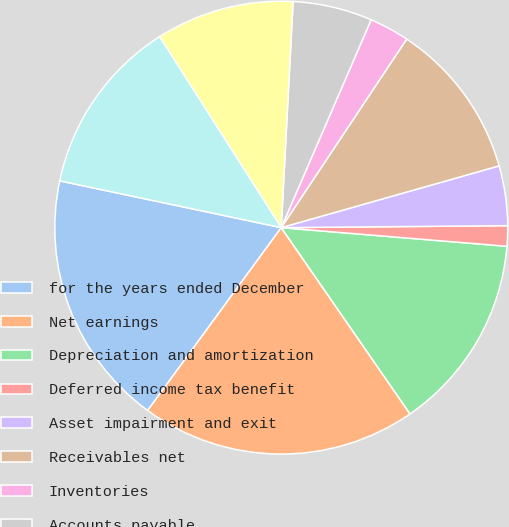Convert chart. <chart><loc_0><loc_0><loc_500><loc_500><pie_chart><fcel>for the years ended December<fcel>Net earnings<fcel>Depreciation and amortization<fcel>Deferred income tax benefit<fcel>Asset impairment and exit<fcel>Receivables net<fcel>Inventories<fcel>Accounts payable<fcel>Income taxes<fcel>Accrued liabilities and other<nl><fcel>18.27%<fcel>19.67%<fcel>14.06%<fcel>1.45%<fcel>4.26%<fcel>11.26%<fcel>2.85%<fcel>5.66%<fcel>9.86%<fcel>12.66%<nl></chart> 